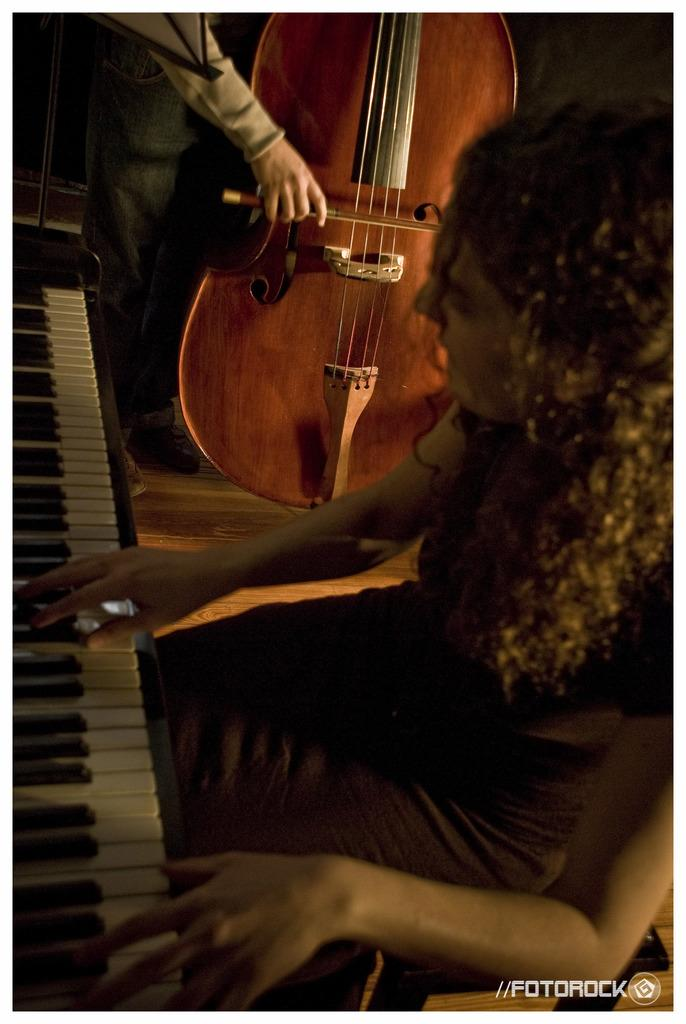Who is the main subject in the image? There is a woman in the image. What is the woman doing in the image? The woman is sitting and playing the keyboard. Is there anyone else in the image besides the woman? Yes, there is a person standing beside the woman. What is the person doing in the image? The person is playing the violin. What type of mask is the woman wearing while playing the keyboard in the image? There is no mask present in the image; the woman is not wearing one while playing the keyboard. What kind of pie is being served to the musicians in the image? There is no pie present in the image; the focus is on the musicians playing their instruments. 